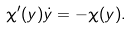Convert formula to latex. <formula><loc_0><loc_0><loc_500><loc_500>\chi ^ { \prime } ( y ) \dot { y } = - \chi ( y ) .</formula> 